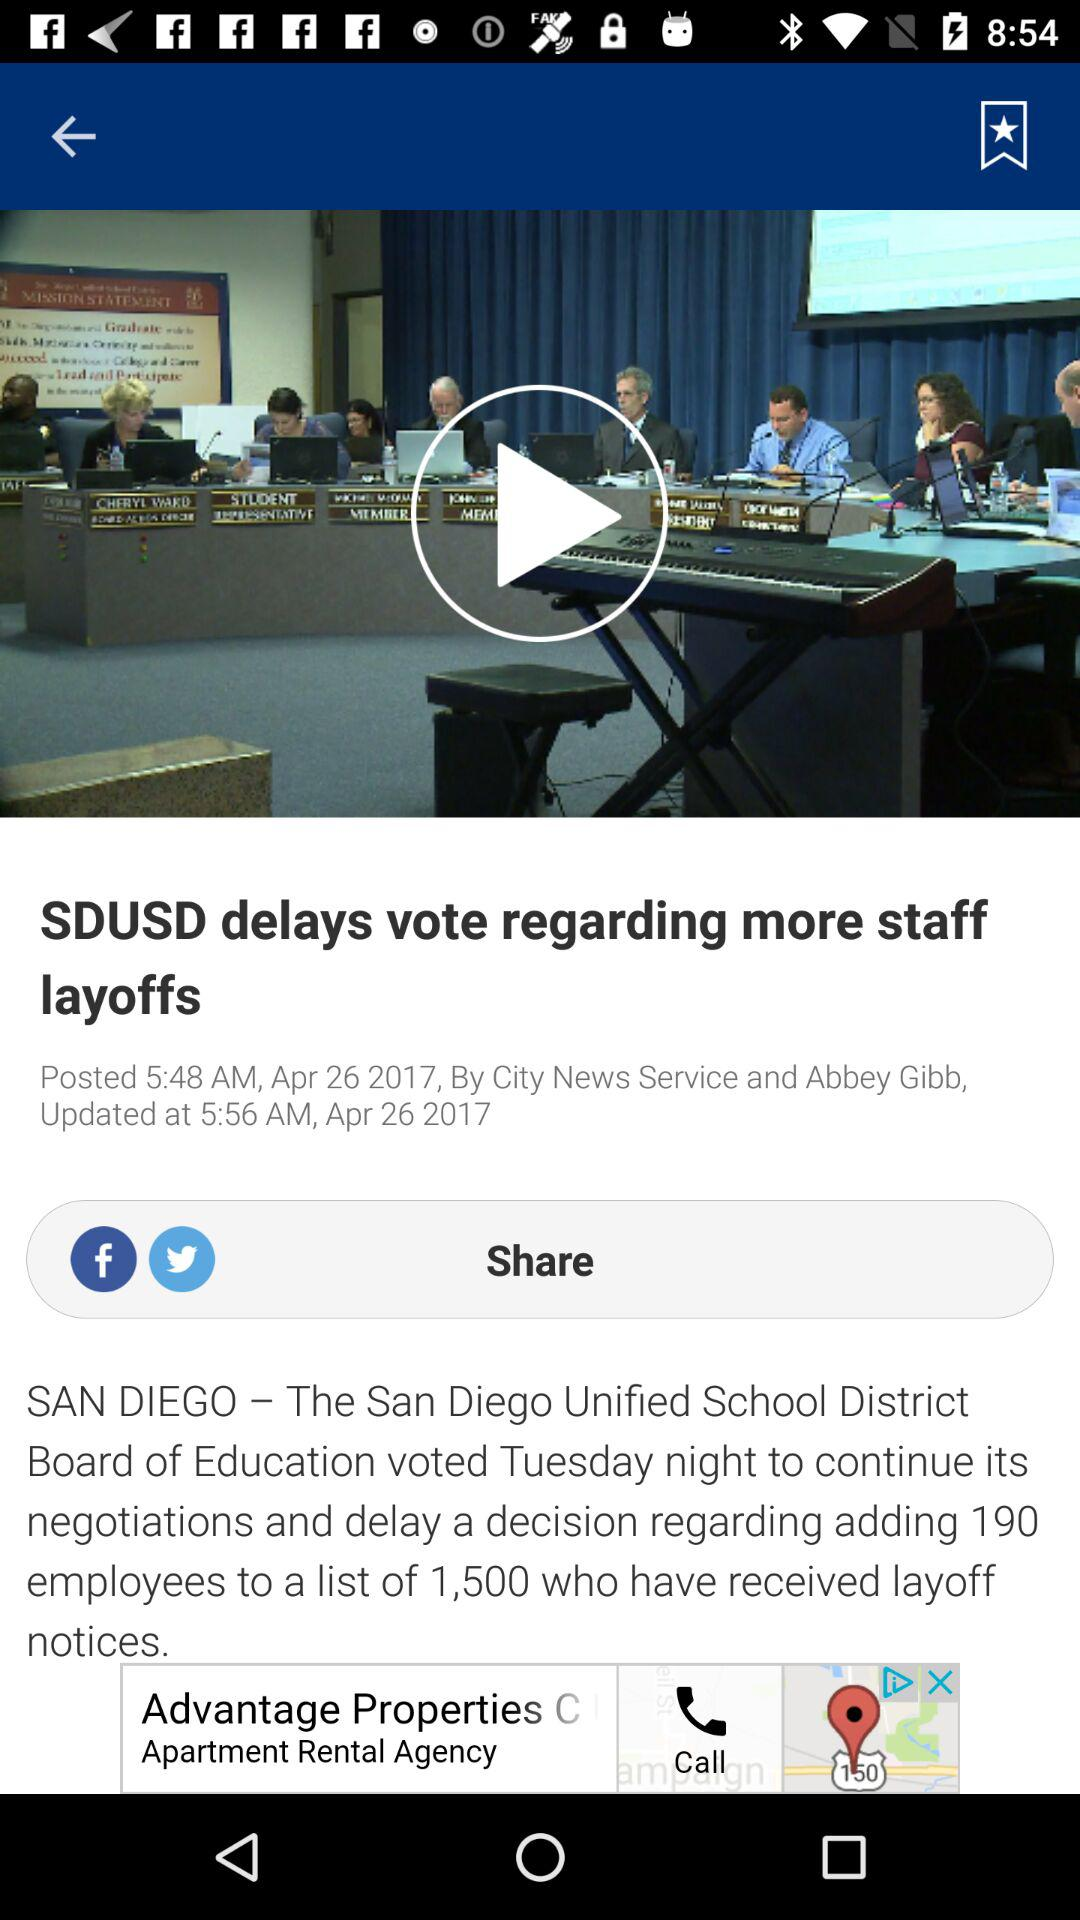When was the article posted? The article was posted on April 26, 2017 at 5:48 am. 